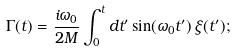<formula> <loc_0><loc_0><loc_500><loc_500>\Gamma ( t ) = { \frac { i \omega _ { 0 } } { 2 M } } \int _ { 0 } ^ { t } d t ^ { \prime } \sin ( \omega _ { 0 } t ^ { \prime } ) \, \xi ( t ^ { \prime } ) ;</formula> 